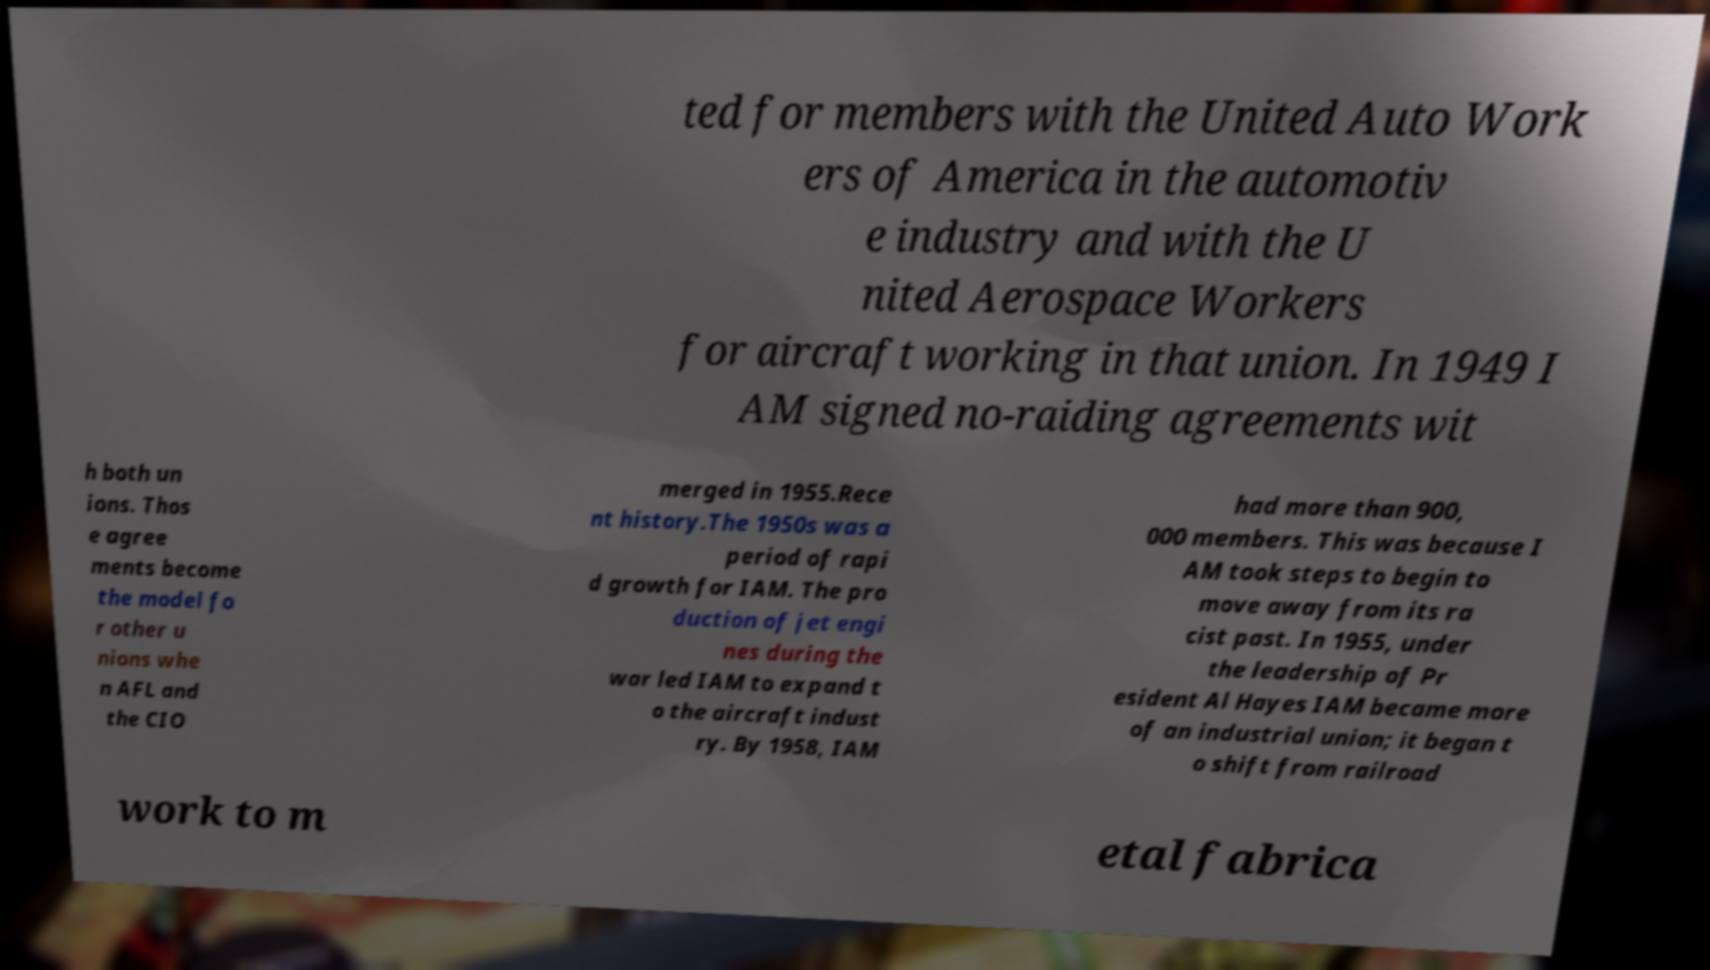Can you read and provide the text displayed in the image?This photo seems to have some interesting text. Can you extract and type it out for me? ted for members with the United Auto Work ers of America in the automotiv e industry and with the U nited Aerospace Workers for aircraft working in that union. In 1949 I AM signed no-raiding agreements wit h both un ions. Thos e agree ments become the model fo r other u nions whe n AFL and the CIO merged in 1955.Rece nt history.The 1950s was a period of rapi d growth for IAM. The pro duction of jet engi nes during the war led IAM to expand t o the aircraft indust ry. By 1958, IAM had more than 900, 000 members. This was because I AM took steps to begin to move away from its ra cist past. In 1955, under the leadership of Pr esident Al Hayes IAM became more of an industrial union; it began t o shift from railroad work to m etal fabrica 